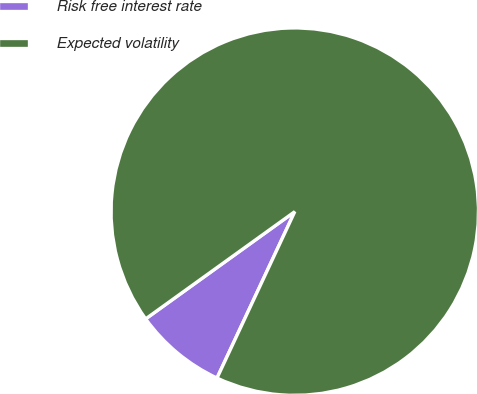Convert chart to OTSL. <chart><loc_0><loc_0><loc_500><loc_500><pie_chart><fcel>Risk free interest rate<fcel>Expected volatility<nl><fcel>8.12%<fcel>91.88%<nl></chart> 